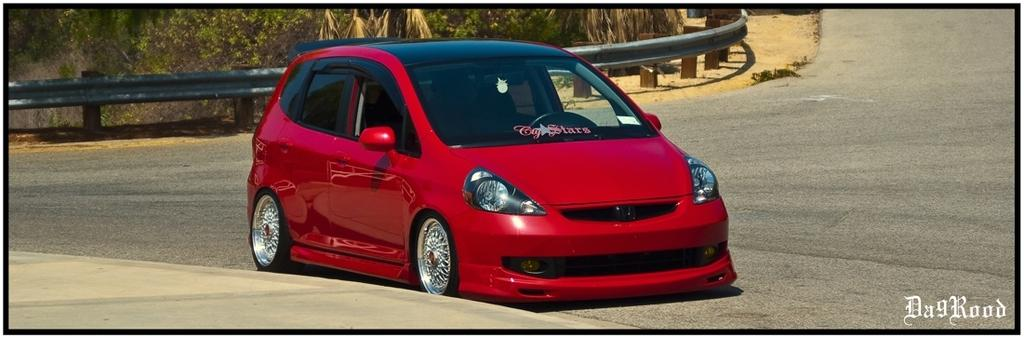What type of vehicle is in the image? There is a red car in the image. What can be seen in the background of the image? There is iron fencing and trees with green color in the background of the image. Can you touch the bag that is hanging from the tree in the image? There is no bag hanging from the tree in the image; it only features iron fencing and green trees in the background. 